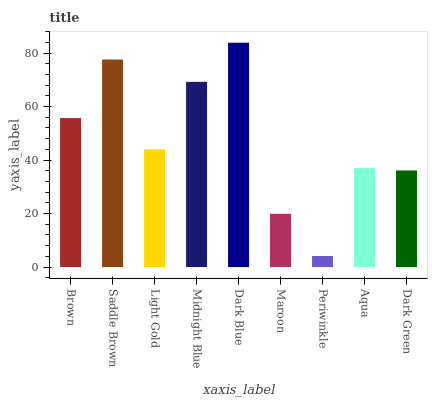Is Periwinkle the minimum?
Answer yes or no. Yes. Is Dark Blue the maximum?
Answer yes or no. Yes. Is Saddle Brown the minimum?
Answer yes or no. No. Is Saddle Brown the maximum?
Answer yes or no. No. Is Saddle Brown greater than Brown?
Answer yes or no. Yes. Is Brown less than Saddle Brown?
Answer yes or no. Yes. Is Brown greater than Saddle Brown?
Answer yes or no. No. Is Saddle Brown less than Brown?
Answer yes or no. No. Is Light Gold the high median?
Answer yes or no. Yes. Is Light Gold the low median?
Answer yes or no. Yes. Is Dark Blue the high median?
Answer yes or no. No. Is Dark Green the low median?
Answer yes or no. No. 